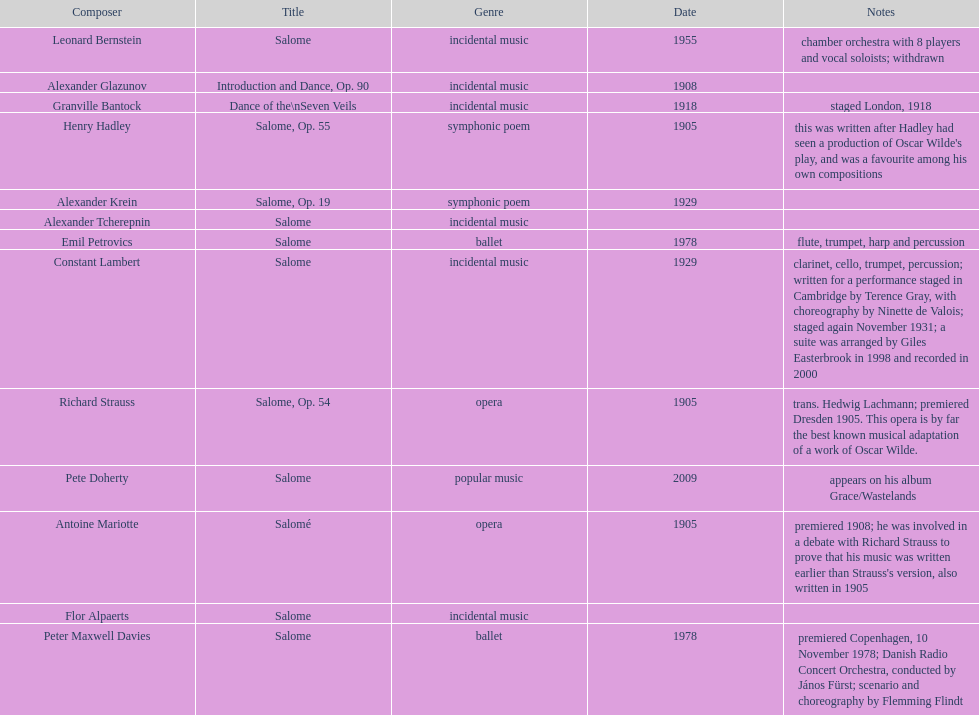Who is next on the list after alexander krein? Constant Lambert. 